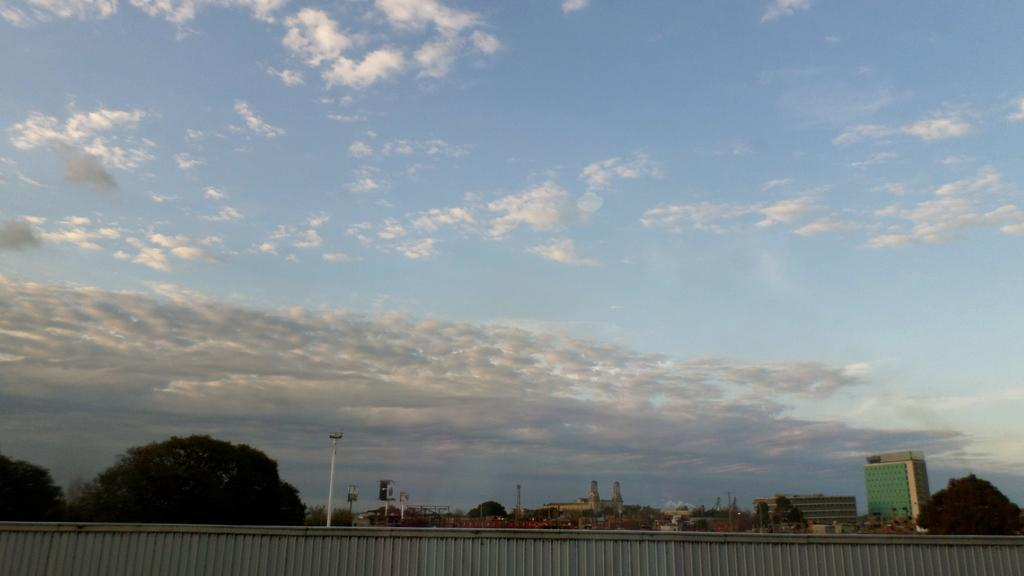What is present in the foreground of the image? There is a wall in the image. What can be seen in the background of the image? There are buildings, poles, hoardings, and trees in the background of the image. How would you describe the sky in the image? The sky is cloudy in the image. How many legs can be seen on the cherry in the image? There is no cherry present in the image, and therefore no legs can be seen on it. 